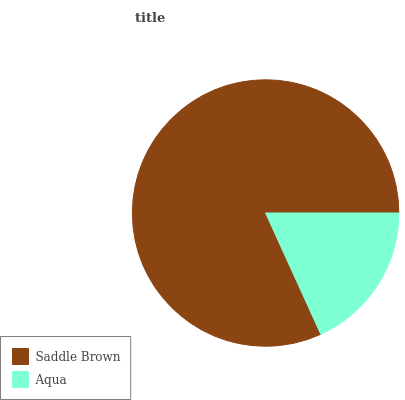Is Aqua the minimum?
Answer yes or no. Yes. Is Saddle Brown the maximum?
Answer yes or no. Yes. Is Aqua the maximum?
Answer yes or no. No. Is Saddle Brown greater than Aqua?
Answer yes or no. Yes. Is Aqua less than Saddle Brown?
Answer yes or no. Yes. Is Aqua greater than Saddle Brown?
Answer yes or no. No. Is Saddle Brown less than Aqua?
Answer yes or no. No. Is Saddle Brown the high median?
Answer yes or no. Yes. Is Aqua the low median?
Answer yes or no. Yes. Is Aqua the high median?
Answer yes or no. No. Is Saddle Brown the low median?
Answer yes or no. No. 